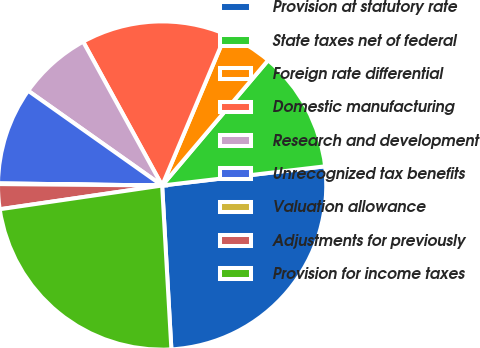Convert chart. <chart><loc_0><loc_0><loc_500><loc_500><pie_chart><fcel>Provision at statutory rate<fcel>State taxes net of federal<fcel>Foreign rate differential<fcel>Domestic manufacturing<fcel>Research and development<fcel>Unrecognized tax benefits<fcel>Valuation allowance<fcel>Adjustments for previously<fcel>Provision for income taxes<nl><fcel>25.97%<fcel>11.96%<fcel>4.83%<fcel>14.34%<fcel>7.21%<fcel>9.59%<fcel>0.07%<fcel>2.45%<fcel>23.59%<nl></chart> 